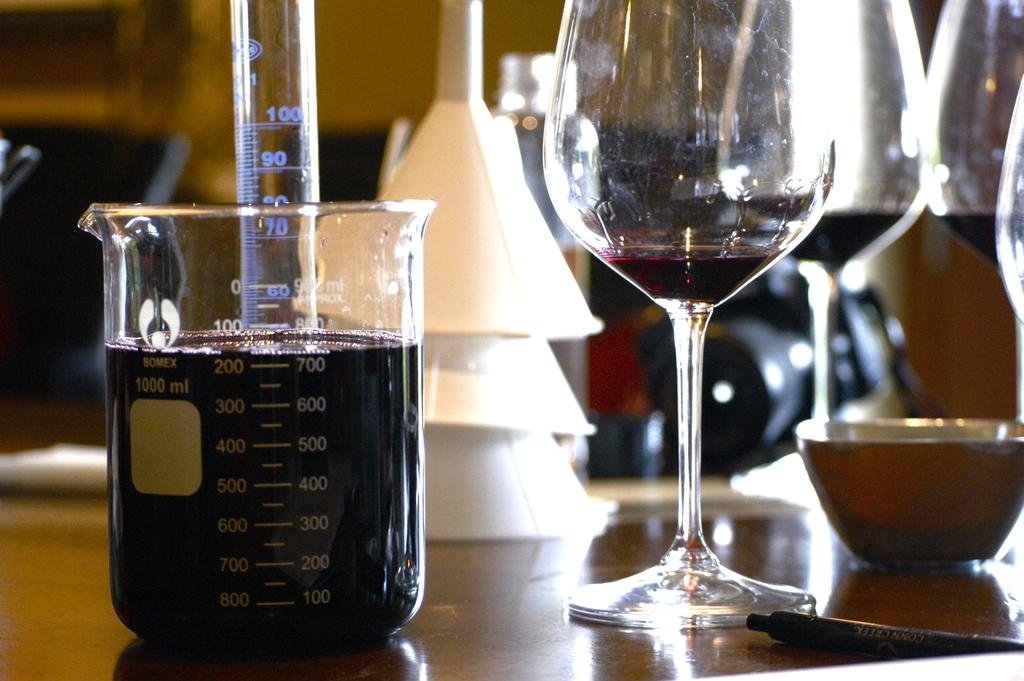<image>
Write a terse but informative summary of the picture. a Bomex beaker is nearly full of wine, sitting by a wine bottle 